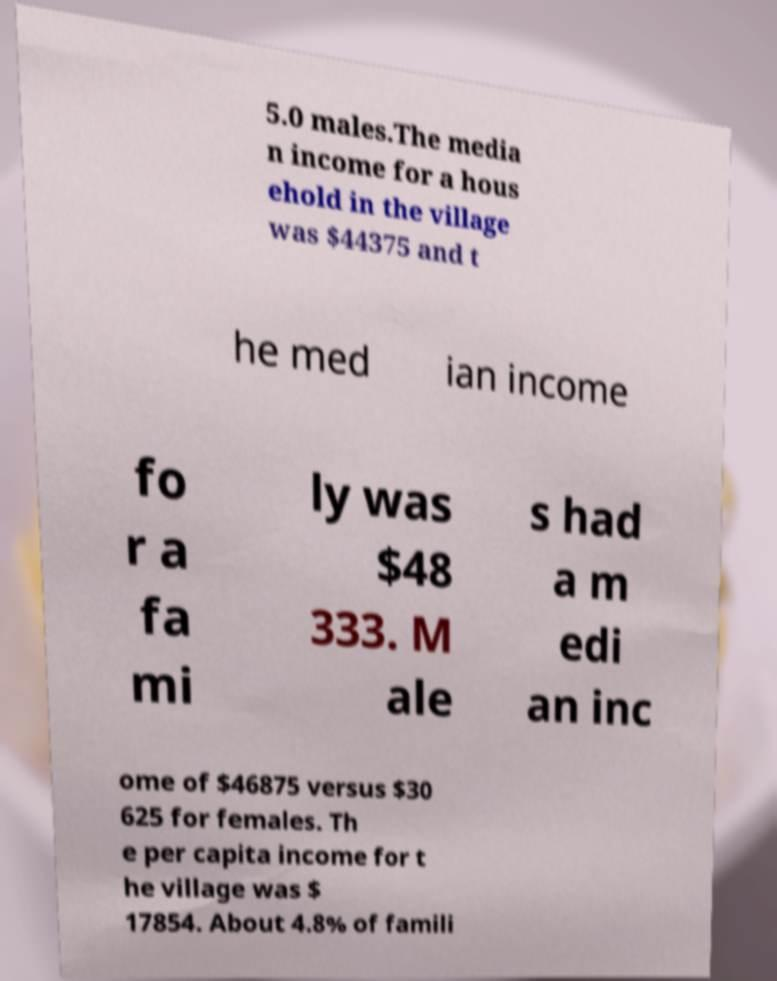Please read and relay the text visible in this image. What does it say? 5.0 males.The media n income for a hous ehold in the village was $44375 and t he med ian income fo r a fa mi ly was $48 333. M ale s had a m edi an inc ome of $46875 versus $30 625 for females. Th e per capita income for t he village was $ 17854. About 4.8% of famili 